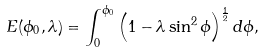<formula> <loc_0><loc_0><loc_500><loc_500>E ( \phi _ { 0 } , \lambda ) = \int _ { 0 } ^ { \phi _ { 0 } } \left ( 1 - \lambda \sin ^ { 2 } \phi \right ) ^ { \frac { 1 } { 2 } } d \phi ,</formula> 